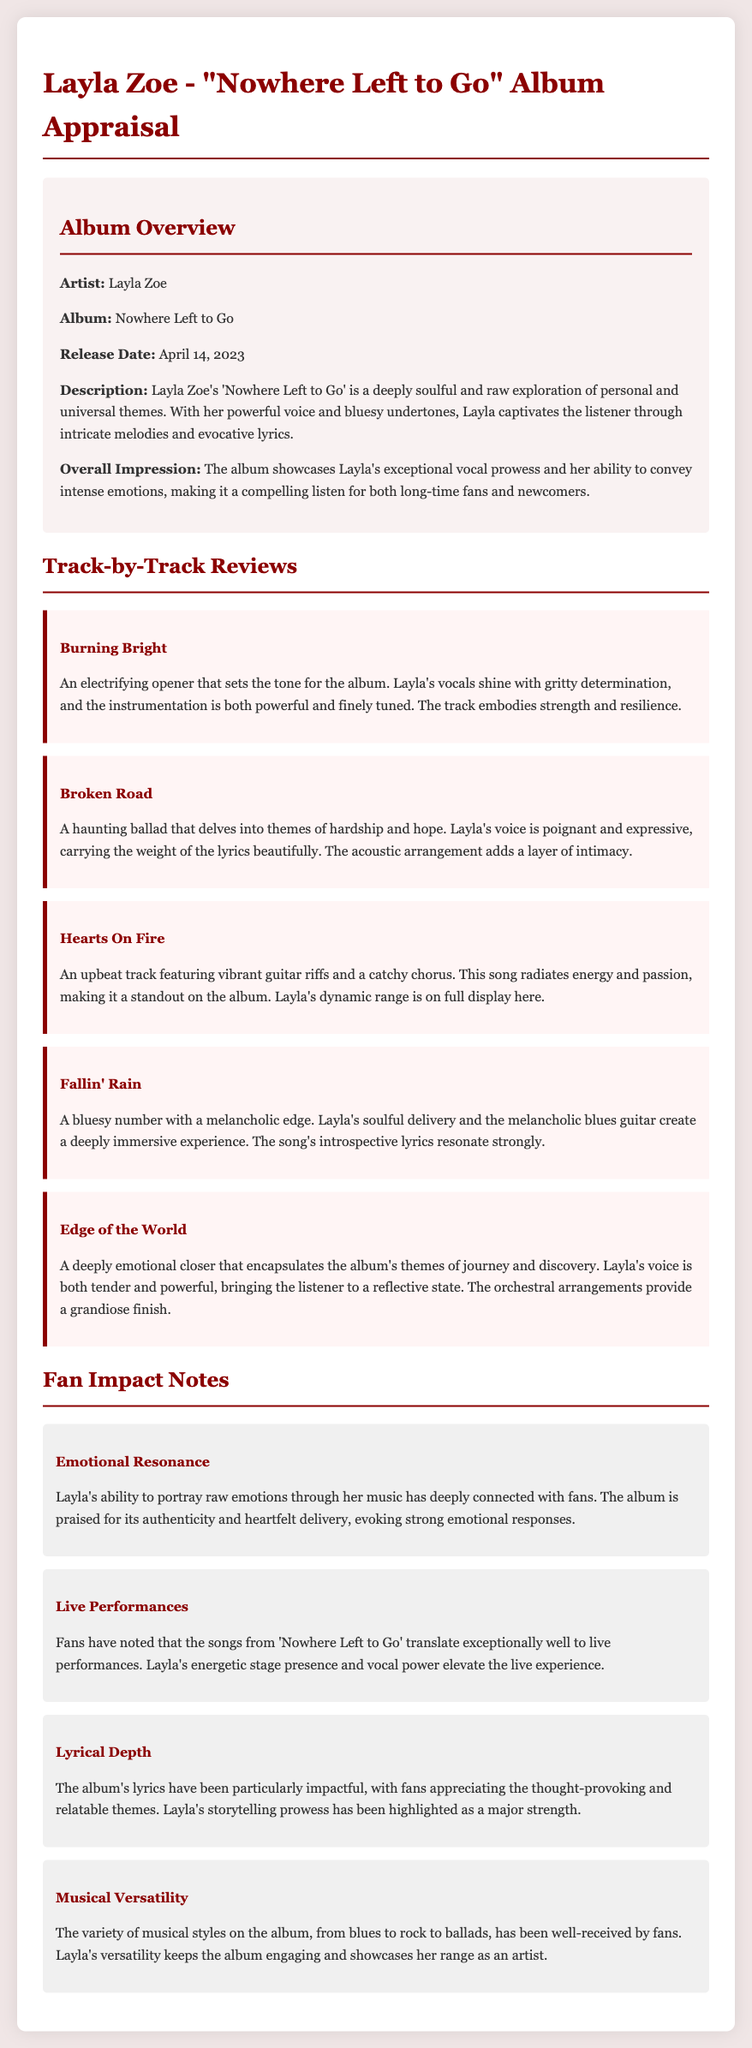What is the album title? The album title is stated in the document, included in the heading where the appraisal begins.
Answer: Nowhere Left to Go Who is the artist? The artist's name appears in the album overview section, clearly labeled.
Answer: Layla Zoe When was the album released? The release date is mentioned in the album overview and provides the specific day.
Answer: April 14, 2023 What is the overall impression of the album? The overall impression is reflected in a specific sentence summarizing the album's emotional impact and musical quality.
Answer: Exceptional vocal prowess How many tracks are reviewed? The number of track reviews can be counted from the track-by-track section of the document.
Answer: Five What themes does "Broken Road" explore? The description associated with "Broken Road" in the document specifies the themes addressed in the song.
Answer: Hardship and hope How do fans feel about Layla's live performances? The fan impact note summarizes how the album's songs are perceived in live settings.
Answer: Exceptional What aspect of lyrics do fans appreciate? The fan impact section discusses fans' views on the lyrics, highlighting what they find impactful.
Answer: Thought-provoking and relatable Which track features vibrant guitar riffs? The track review detailing the instrumentation also mentions the track by name.
Answer: Hearts On Fire What is one musical style showcased in the album? The fan impact section mentions the variety of styles present in the album.
Answer: Blues 